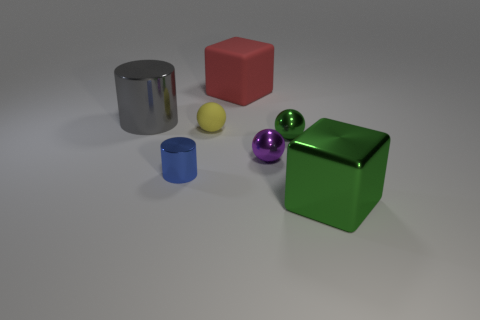There is another large thing that is the same shape as the big red matte thing; what color is it?
Make the answer very short. Green. Are there any big gray cylinders?
Your response must be concise. Yes. Is the tiny ball in front of the green sphere made of the same material as the big gray object on the left side of the large rubber cube?
Your answer should be compact. Yes. There is a small metal object that is the same color as the large metal block; what is its shape?
Provide a short and direct response. Sphere. What number of things are either things that are in front of the large shiny cylinder or green metallic balls in front of the tiny yellow object?
Your answer should be compact. 5. There is a big cylinder left of the large green object; is its color the same as the small ball on the left side of the tiny purple sphere?
Give a very brief answer. No. The thing that is to the left of the tiny matte sphere and in front of the yellow rubber thing has what shape?
Your response must be concise. Cylinder. What is the color of the metallic cylinder that is the same size as the red object?
Keep it short and to the point. Gray. Is there a rubber cylinder that has the same color as the large shiny block?
Your response must be concise. No. Do the metal cylinder that is to the left of the tiny blue shiny thing and the matte object that is to the left of the big red matte cube have the same size?
Keep it short and to the point. No. 